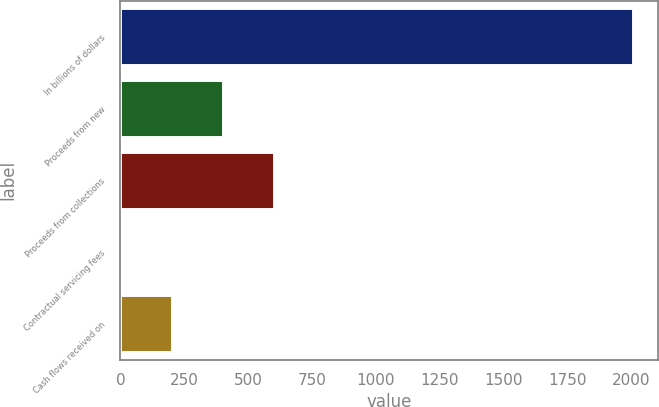Convert chart. <chart><loc_0><loc_0><loc_500><loc_500><bar_chart><fcel>In billions of dollars<fcel>Proceeds from new<fcel>Proceeds from collections<fcel>Contractual servicing fees<fcel>Cash flows received on<nl><fcel>2007<fcel>403.08<fcel>603.57<fcel>2.1<fcel>202.59<nl></chart> 